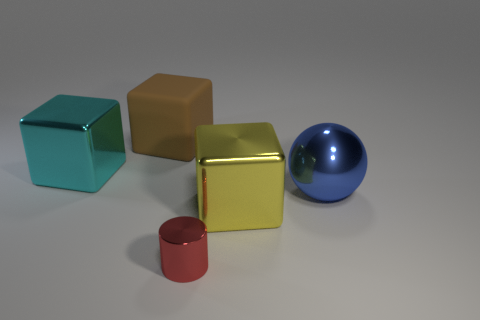Add 3 small gray metal cylinders. How many objects exist? 8 Subtract all gray spheres. Subtract all purple blocks. How many spheres are left? 1 Subtract all cubes. How many objects are left? 2 Subtract 1 blue balls. How many objects are left? 4 Subtract all green balls. Subtract all large yellow metal objects. How many objects are left? 4 Add 3 large matte blocks. How many large matte blocks are left? 4 Add 2 rubber objects. How many rubber objects exist? 3 